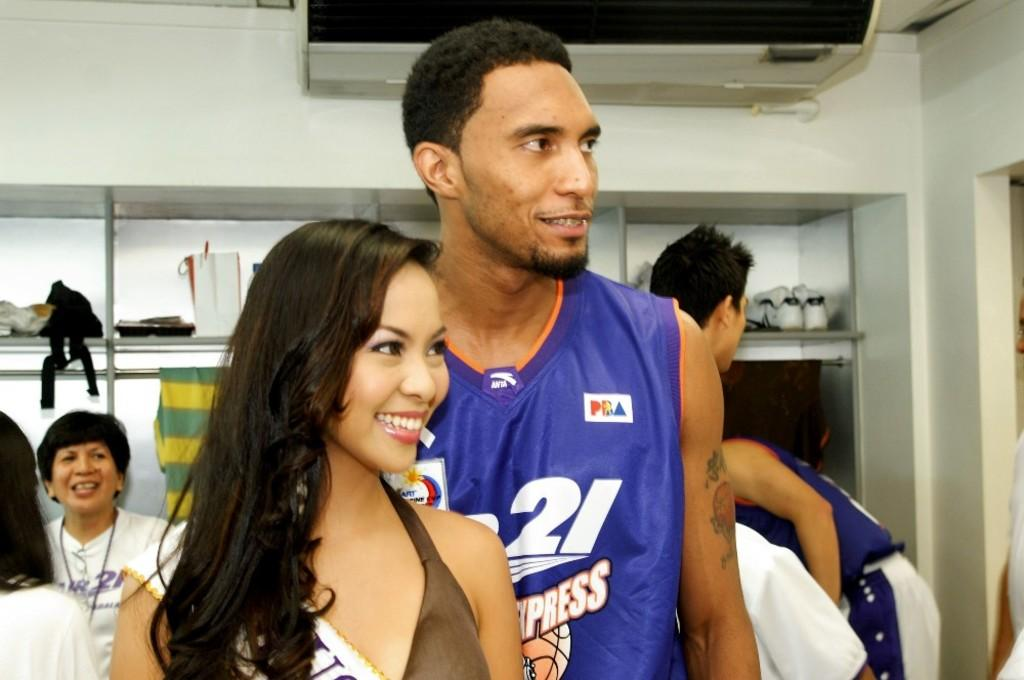<image>
Present a compact description of the photo's key features. Player wearing jersey number 21 taking a picture with a lady. 